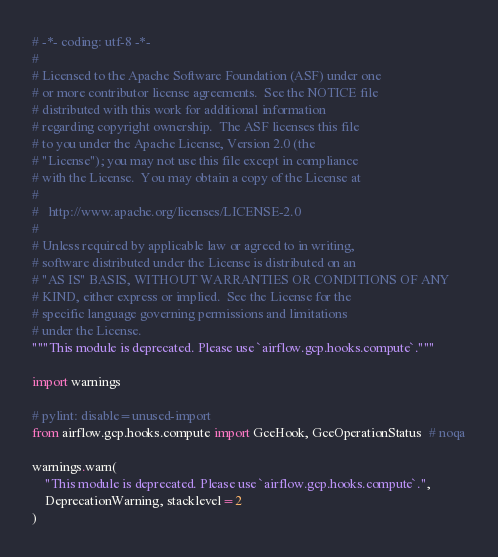Convert code to text. <code><loc_0><loc_0><loc_500><loc_500><_Python_># -*- coding: utf-8 -*-
#
# Licensed to the Apache Software Foundation (ASF) under one
# or more contributor license agreements.  See the NOTICE file
# distributed with this work for additional information
# regarding copyright ownership.  The ASF licenses this file
# to you under the Apache License, Version 2.0 (the
# "License"); you may not use this file except in compliance
# with the License.  You may obtain a copy of the License at
#
#   http://www.apache.org/licenses/LICENSE-2.0
#
# Unless required by applicable law or agreed to in writing,
# software distributed under the License is distributed on an
# "AS IS" BASIS, WITHOUT WARRANTIES OR CONDITIONS OF ANY
# KIND, either express or implied.  See the License for the
# specific language governing permissions and limitations
# under the License.
"""This module is deprecated. Please use `airflow.gcp.hooks.compute`."""

import warnings

# pylint: disable=unused-import
from airflow.gcp.hooks.compute import GceHook, GceOperationStatus  # noqa

warnings.warn(
    "This module is deprecated. Please use `airflow.gcp.hooks.compute`.",
    DeprecationWarning, stacklevel=2
)
</code> 